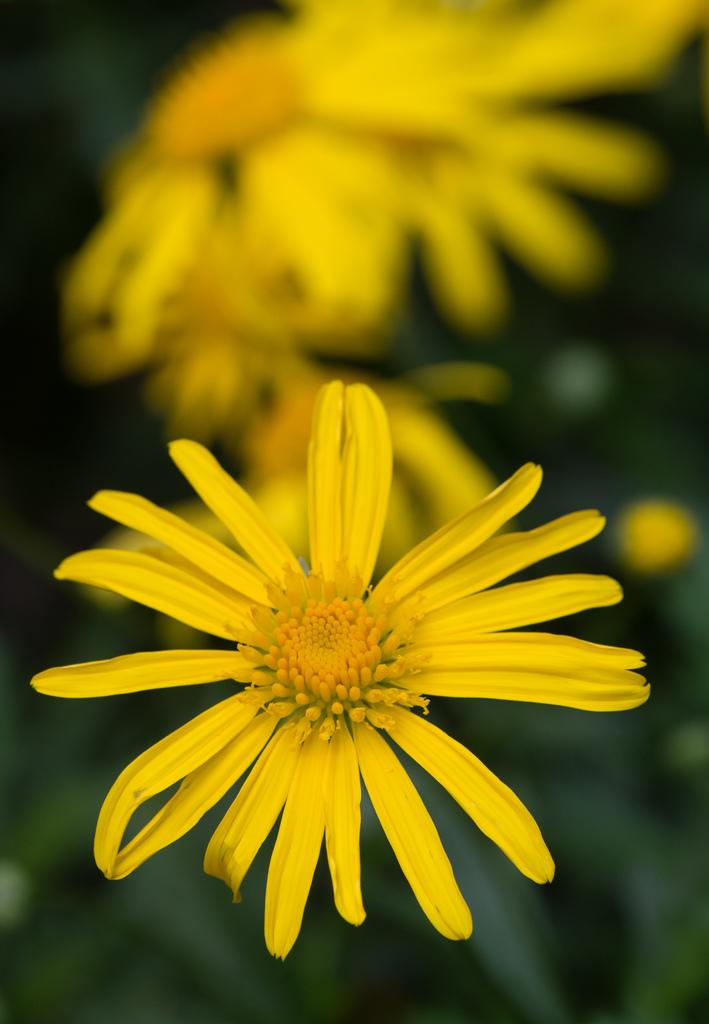What type of plants can be seen in the image? There are flowers in the image. What color are the flowers? The flowers are yellow. What type of texture can be felt on the dog's fur in the image? There is no dog present in the image, so there is no fur texture to describe. 